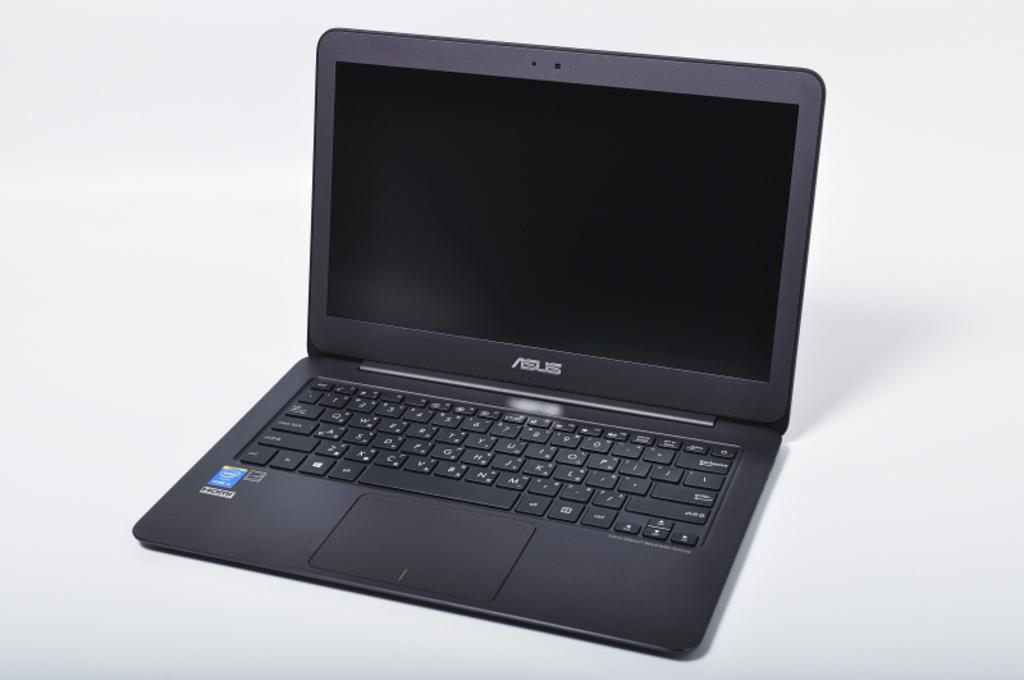<image>
Create a compact narrative representing the image presented. A laptop whose brand name ends with S sits on a white table. 